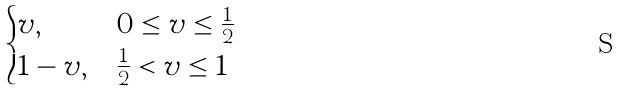<formula> <loc_0><loc_0><loc_500><loc_500>\begin{cases} v , & 0 \leq v \leq \frac { 1 } { 2 } \\ 1 - v , & \frac { 1 } { 2 } < v \leq 1 \end{cases}</formula> 